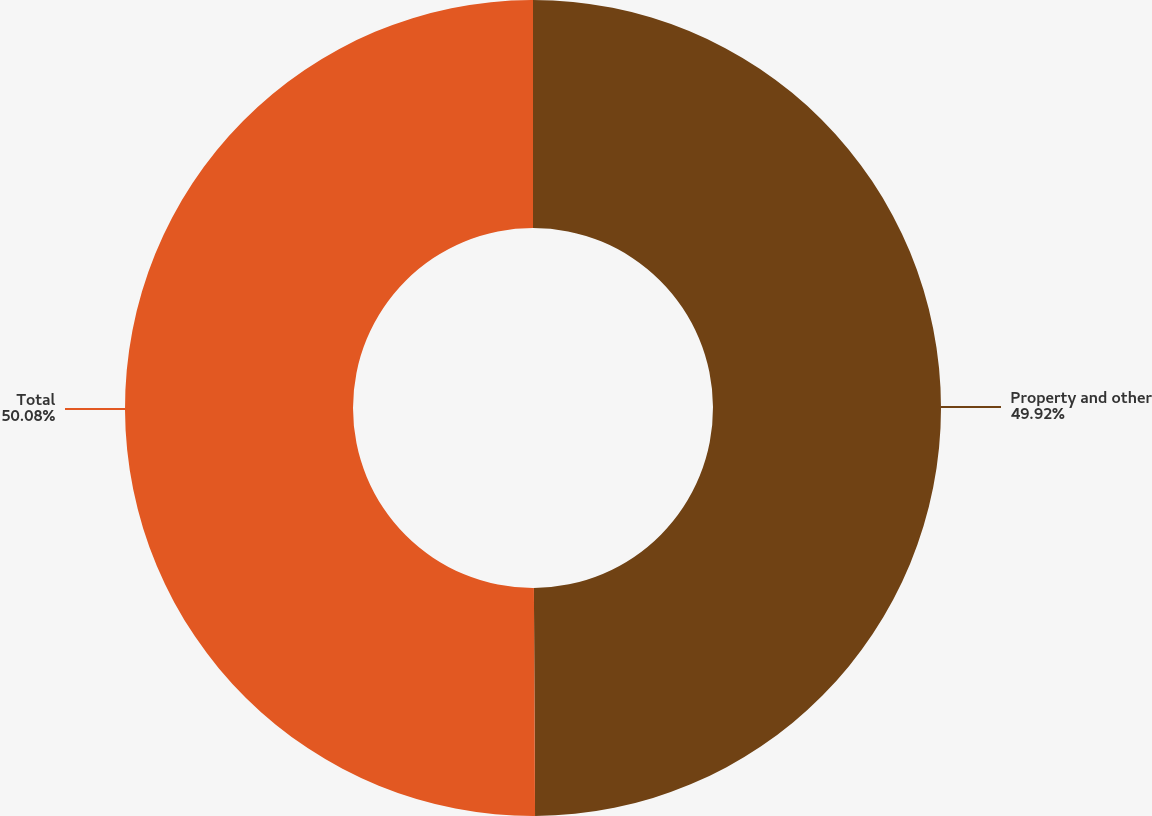<chart> <loc_0><loc_0><loc_500><loc_500><pie_chart><fcel>Property and other<fcel>Total<nl><fcel>49.92%<fcel>50.08%<nl></chart> 